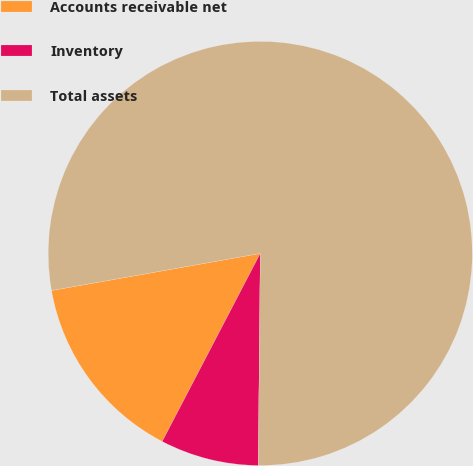<chart> <loc_0><loc_0><loc_500><loc_500><pie_chart><fcel>Accounts receivable net<fcel>Inventory<fcel>Total assets<nl><fcel>14.55%<fcel>7.5%<fcel>77.95%<nl></chart> 